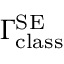Convert formula to latex. <formula><loc_0><loc_0><loc_500><loc_500>\Gamma _ { c l a s s } ^ { S E }</formula> 